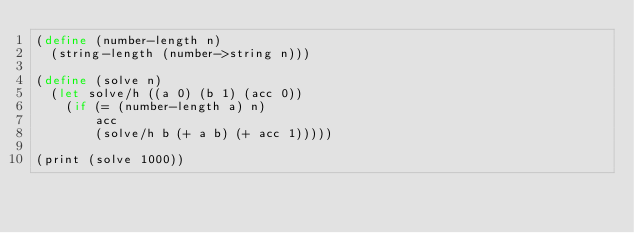<code> <loc_0><loc_0><loc_500><loc_500><_Scheme_>(define (number-length n)
  (string-length (number->string n)))

(define (solve n)
  (let solve/h ((a 0) (b 1) (acc 0))
    (if (= (number-length a) n)
        acc
        (solve/h b (+ a b) (+ acc 1)))))

(print (solve 1000))
</code> 